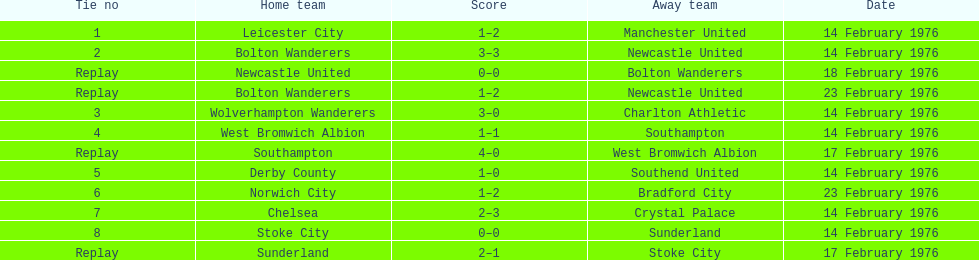Which teams took part in matches on the same day as the leicester city and manchester united game? Bolton Wanderers, Newcastle United. 